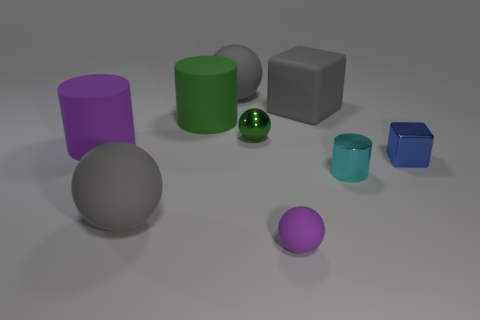There is a cylinder that is the same color as the shiny ball; what size is it?
Provide a succinct answer. Large. Is the number of rubber blocks that are to the left of the purple cylinder greater than the number of green balls?
Ensure brevity in your answer.  No. What shape is the tiny thing that is to the left of the blue cube and to the right of the gray rubber block?
Ensure brevity in your answer.  Cylinder. Do the shiny block and the purple ball have the same size?
Ensure brevity in your answer.  Yes. There is a big green matte cylinder; what number of purple rubber things are on the left side of it?
Give a very brief answer. 1. Are there the same number of big purple cylinders in front of the blue cube and tiny blue things that are in front of the purple rubber ball?
Ensure brevity in your answer.  Yes. Do the purple thing that is right of the big purple matte cylinder and the big purple object have the same shape?
Your answer should be very brief. No. Is there any other thing that has the same material as the green ball?
Provide a succinct answer. Yes. There is a cyan cylinder; is it the same size as the gray matte ball in front of the tiny cyan shiny thing?
Your response must be concise. No. How many other things are the same color as the shiny block?
Offer a terse response. 0. 